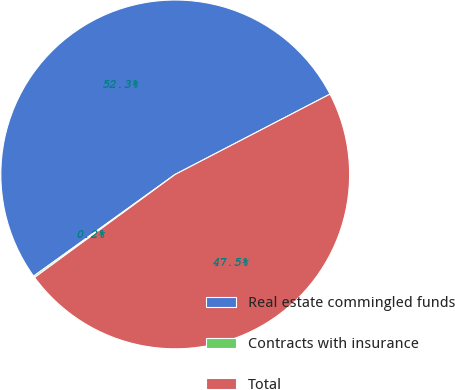Convert chart. <chart><loc_0><loc_0><loc_500><loc_500><pie_chart><fcel>Real estate commingled funds<fcel>Contracts with insurance<fcel>Total<nl><fcel>52.3%<fcel>0.15%<fcel>47.55%<nl></chart> 